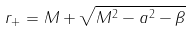<formula> <loc_0><loc_0><loc_500><loc_500>r _ { + } = M + \sqrt { M ^ { 2 } - a ^ { 2 } - \beta } \,</formula> 